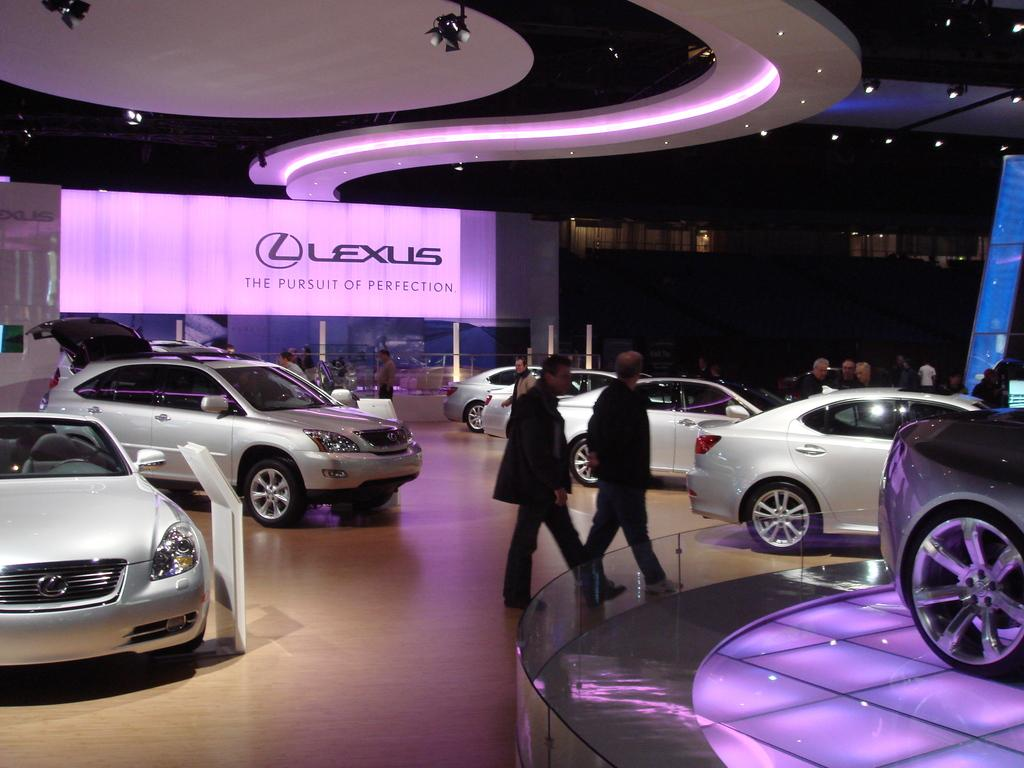What is the main subject in the image? There is a vehicle in the image. What else can be seen in the middle of the image? There are people standing in the middle of the image. What is visible above the people in the image? There is a ceiling visible in the image. What is present in the background of the image? There is a banner in the background of the image, and there is text on the banner. What type of game is being played in the image? There is no game present in the image. 